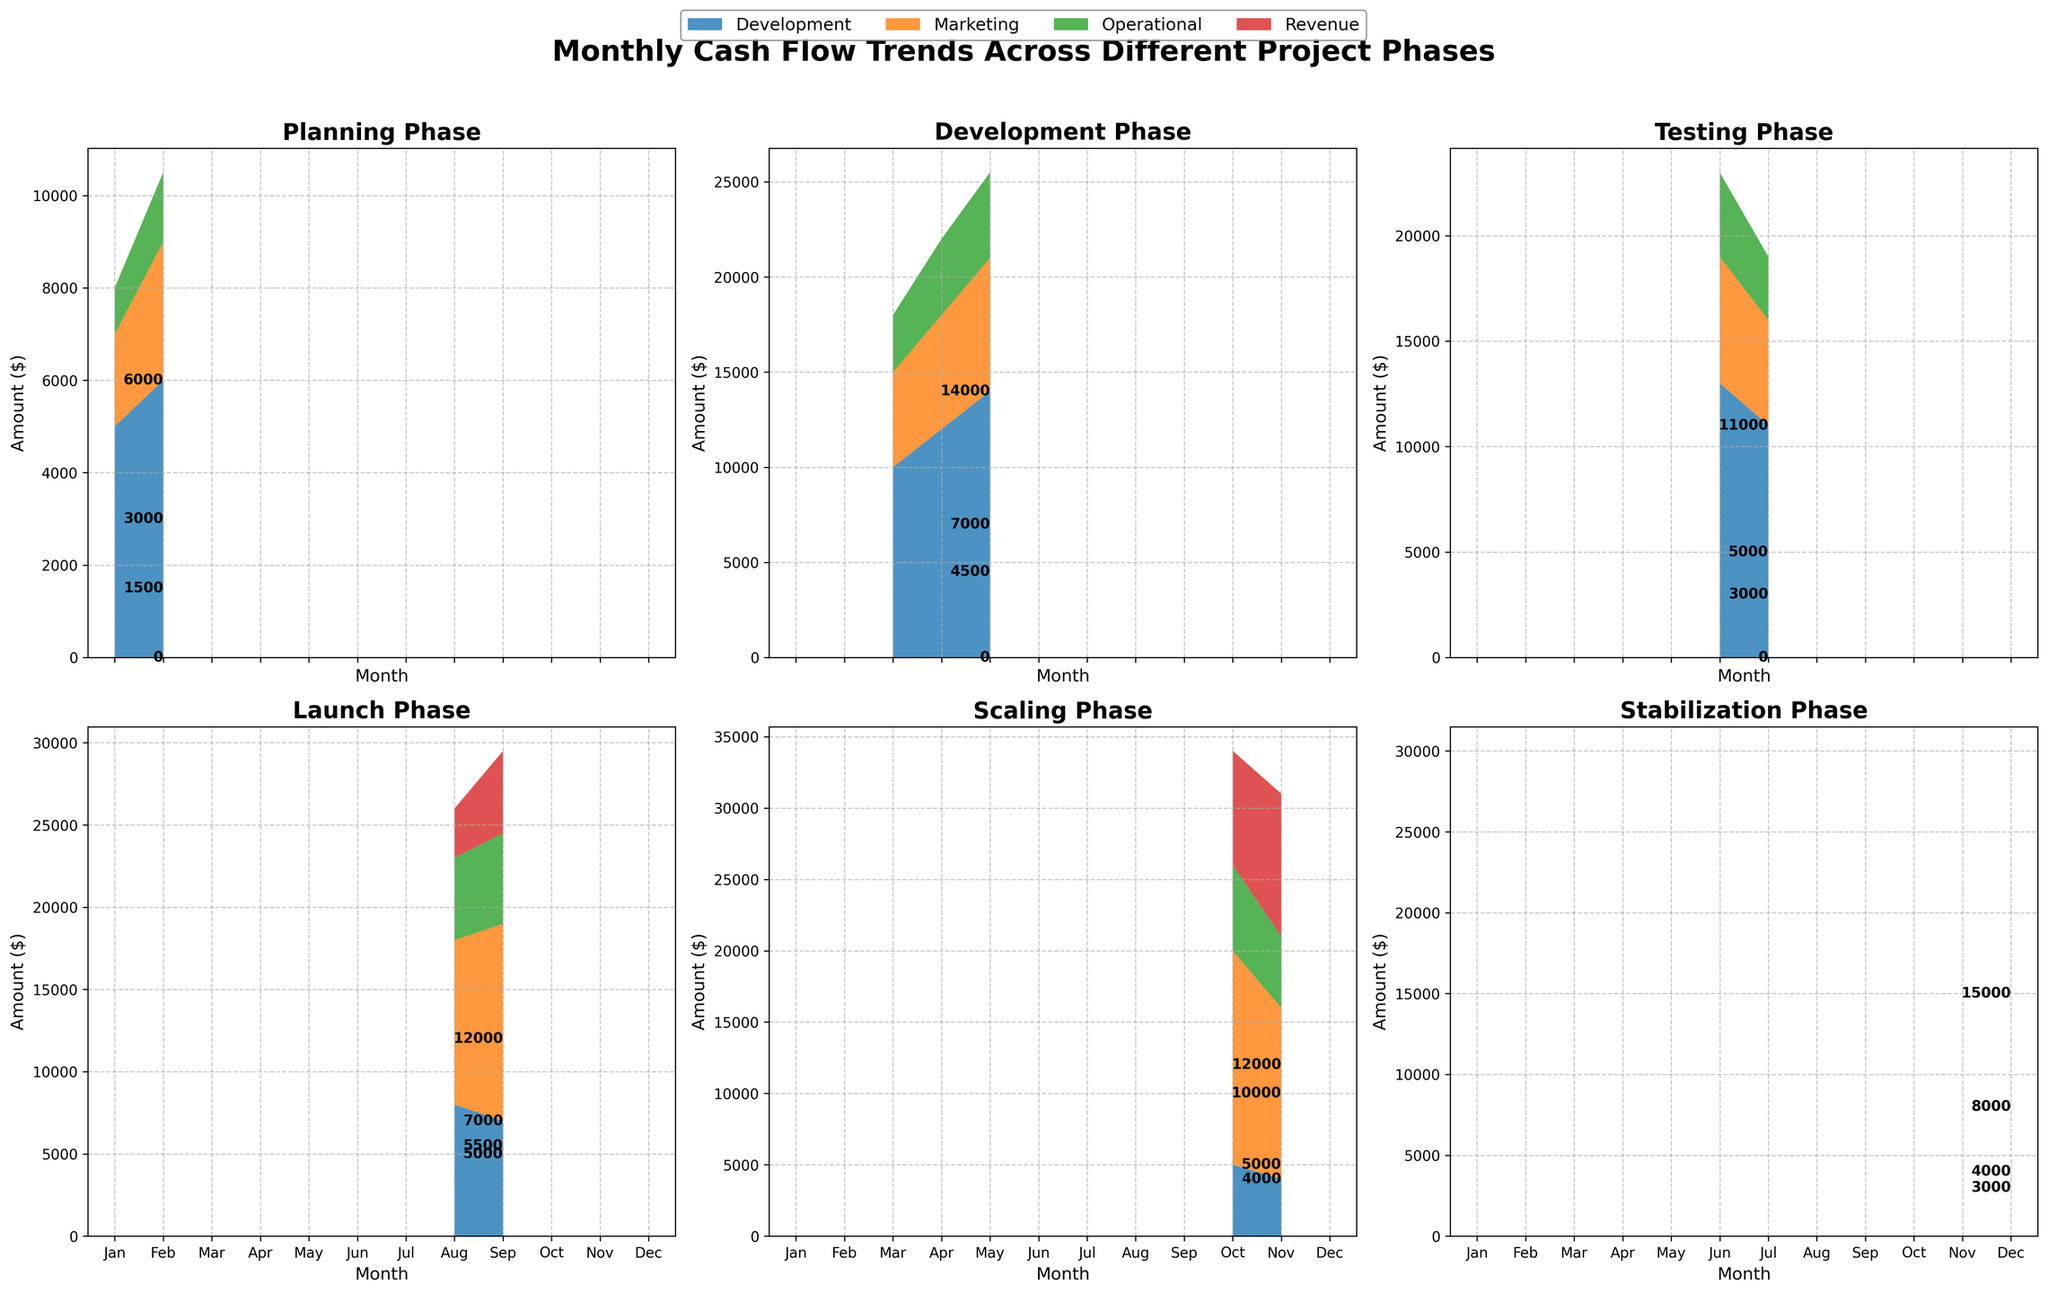What is the title of the figure? The title of the figure is located at the top and summarizes the overall content.
Answer: Monthly Cash Flow Trends Across Different Project Phases How many subplots are there in total? By counting the individual visual sections of the figure, you can determine there are six subplots, each representing a different project phase.
Answer: 6 In which phase does the Revenue first appear, and in which month? To determine this, we look through the subplots to find the first instance where the Revenue portion (indicated by its respective color) appears. It first appears in the Launch phase during August.
Answer: Launch phase, August Which phase has the highest combined costs (Development, Marketing, Operational) in any given month and what is that total? We need to look at each subplot and sum the Development, Marketing, and Operational costs for each month, then identify the highest value. This occurs in the Development phase during May, where the combined costs are 14,000 + 7,000 + 4,500 = 25,500.
Answer: Development phase, 25,500 During the Stabilization phase in December, what is the revenue, and how does it compare to the combined costs? For December in the Stabilization phase, the subplot shows the Revenue is 15,000. Adding up the Development, Marketing, and Operational costs gives 3,000 + 8,000 + 4,000 = 15,000. The Revenue is equal to the combined costs.
Answer: Revenue is 15,000, equal to the combined costs What is the general trend of Marketing Costs from the Launch phase to the Scaling phase? Reviewing the months in the Launch and Scaling phases, we see that Marketing Costs increase from 10,000 in August to 12,000 in September, then rise to 15,000 in October before dipping to 12,000 in November. The general trend is an increase.
Answer: Increasing trend How does the Development Costs in the Testing phase compare to the Development Costs in the Launch phase? For the Testing phase, June and July have Development Costs of 13,000 and 11,000 respectively. In the Launch phase, August and September have 8,000 and 7,000 respectively. Testing phase has higher Development Costs compared to the Launch phase.
Answer: Testing phase has higher Development Costs In which phase do operational costs remain constant, and what is that constant value? By inspecting the respective sections, we observe that in the Launch phase, Operational Costs are consistently depicted at 5,000 and 5,500 for August and September. Additionally, in the Testing phase, Operational Costs are 4,000.
Answer: Testing phase, 4,000 What can you infer about the project's revenue over time looking at the figure? By following the Revenue across all project phases from Planning to Stabilization, it starts appearing from Launch phase and increases steadily, peaking in the Stabilization phase. This indicates that the project starts earning revenue after launch and it grows over time.
Answer: Increases over time What is the phase where Marketing Costs surpass Development Costs significantly, and by how much? Reviewing the figure, we see that in the Scaling phase, Marketing Costs are 15,000 and Development Costs are 5,000 in October. The difference is 15,000 - 5,000 = 10,000, indicating a significant surpassing.
Answer: Scaling phase, by 10,000 